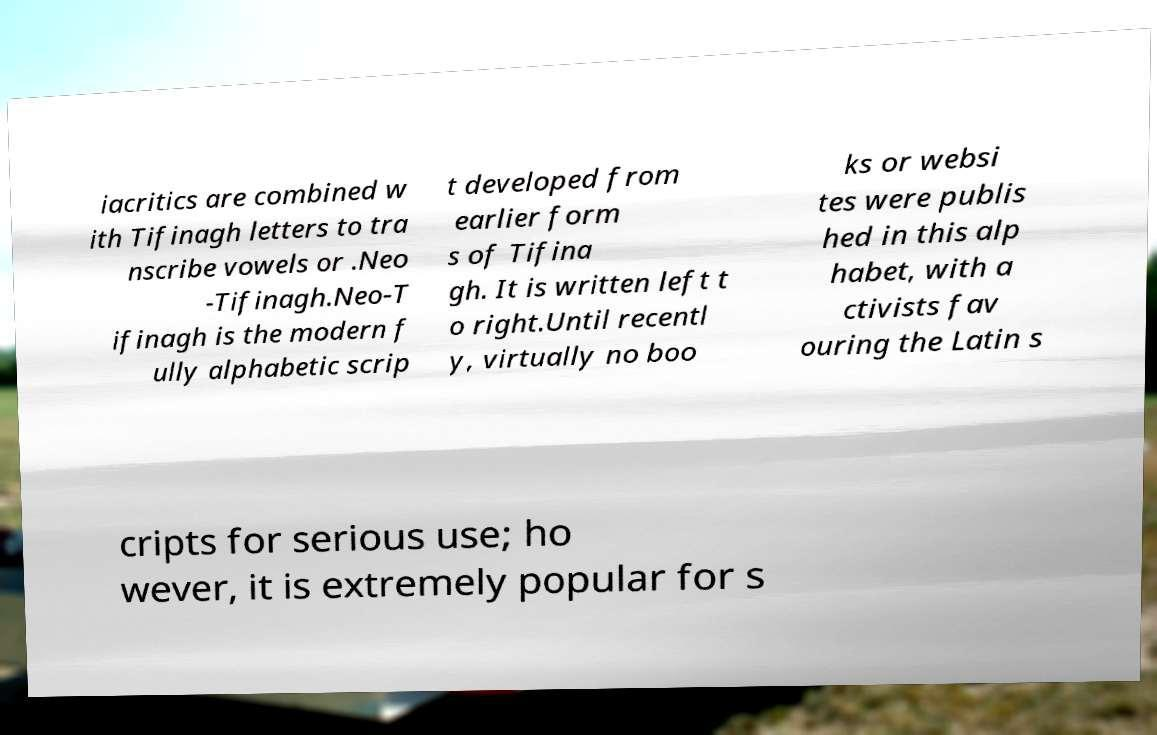What messages or text are displayed in this image? I need them in a readable, typed format. iacritics are combined w ith Tifinagh letters to tra nscribe vowels or .Neo -Tifinagh.Neo-T ifinagh is the modern f ully alphabetic scrip t developed from earlier form s of Tifina gh. It is written left t o right.Until recentl y, virtually no boo ks or websi tes were publis hed in this alp habet, with a ctivists fav ouring the Latin s cripts for serious use; ho wever, it is extremely popular for s 